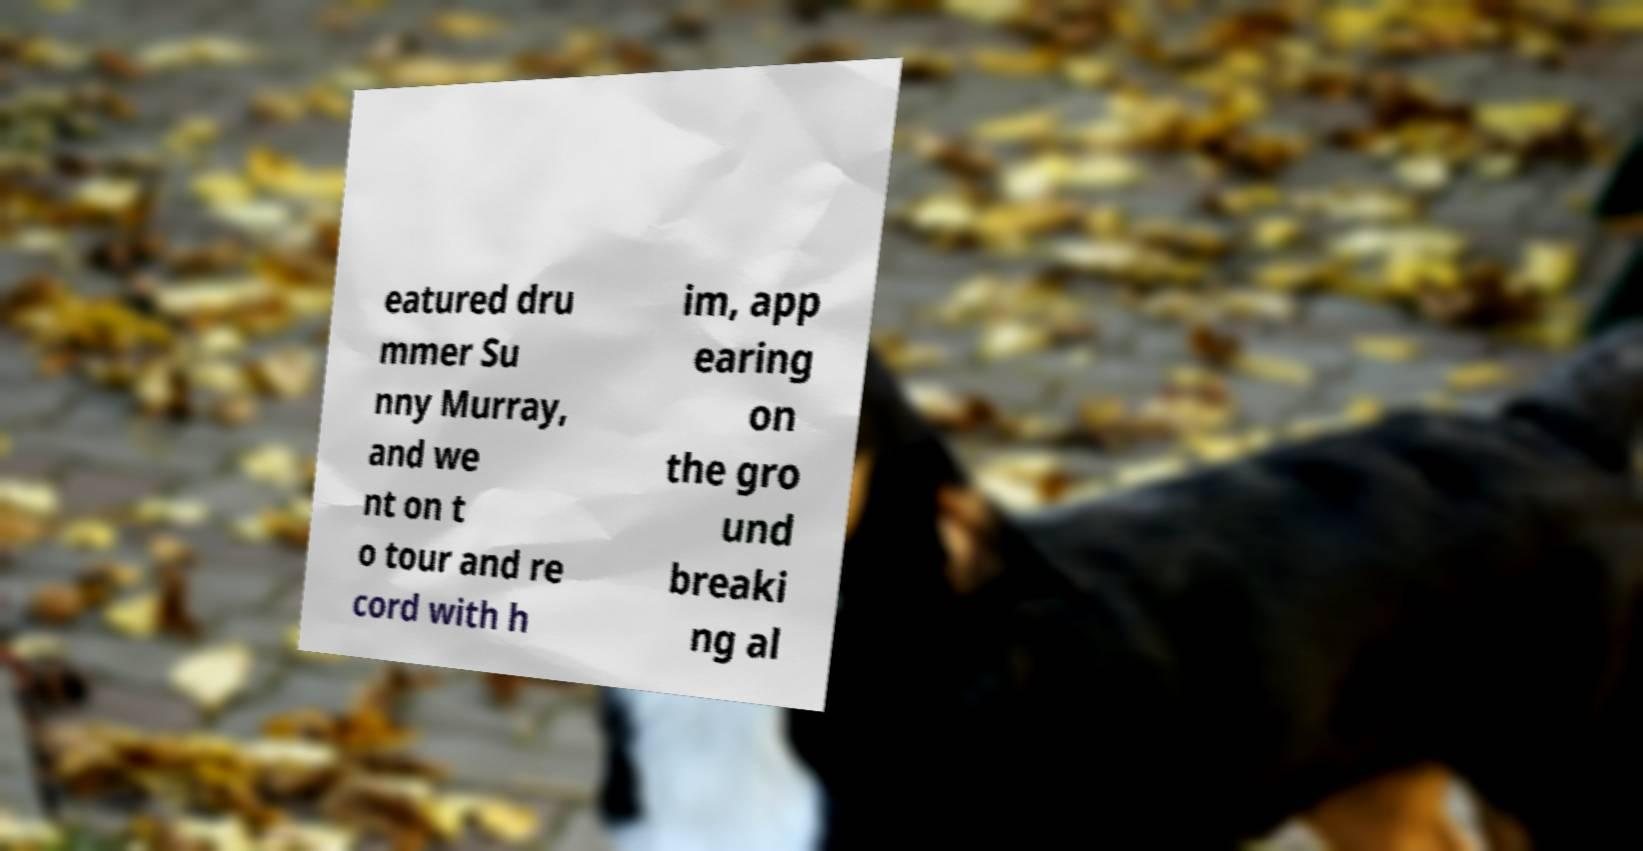Please read and relay the text visible in this image. What does it say? eatured dru mmer Su nny Murray, and we nt on t o tour and re cord with h im, app earing on the gro und breaki ng al 